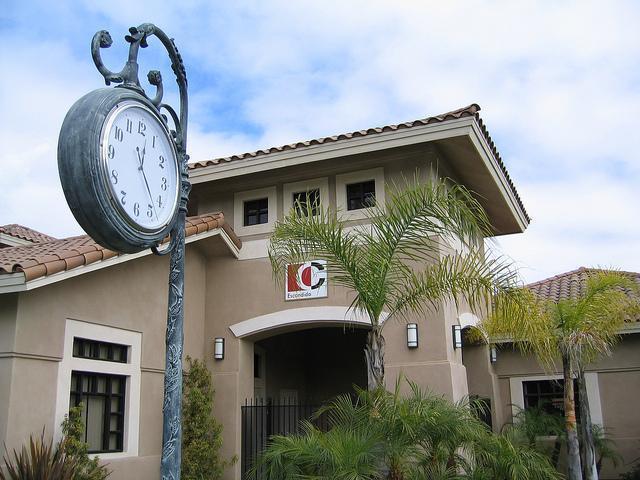How many clocks are there?
Give a very brief answer. 1. 